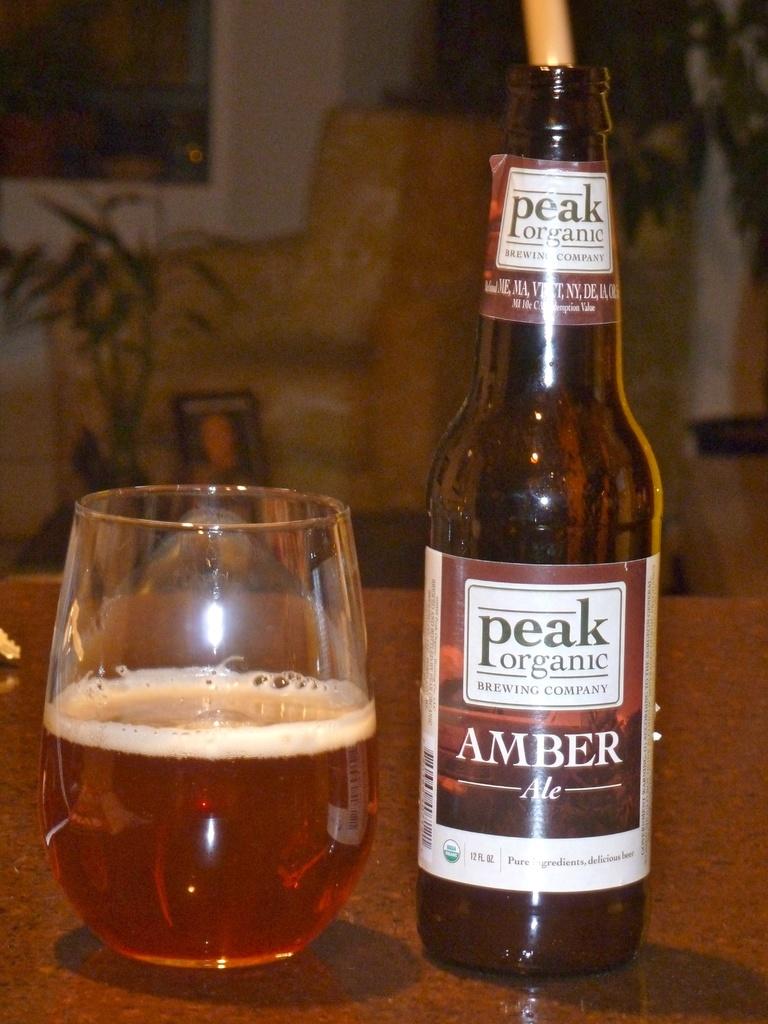How many ounces are in this beer?
Ensure brevity in your answer.  12. 